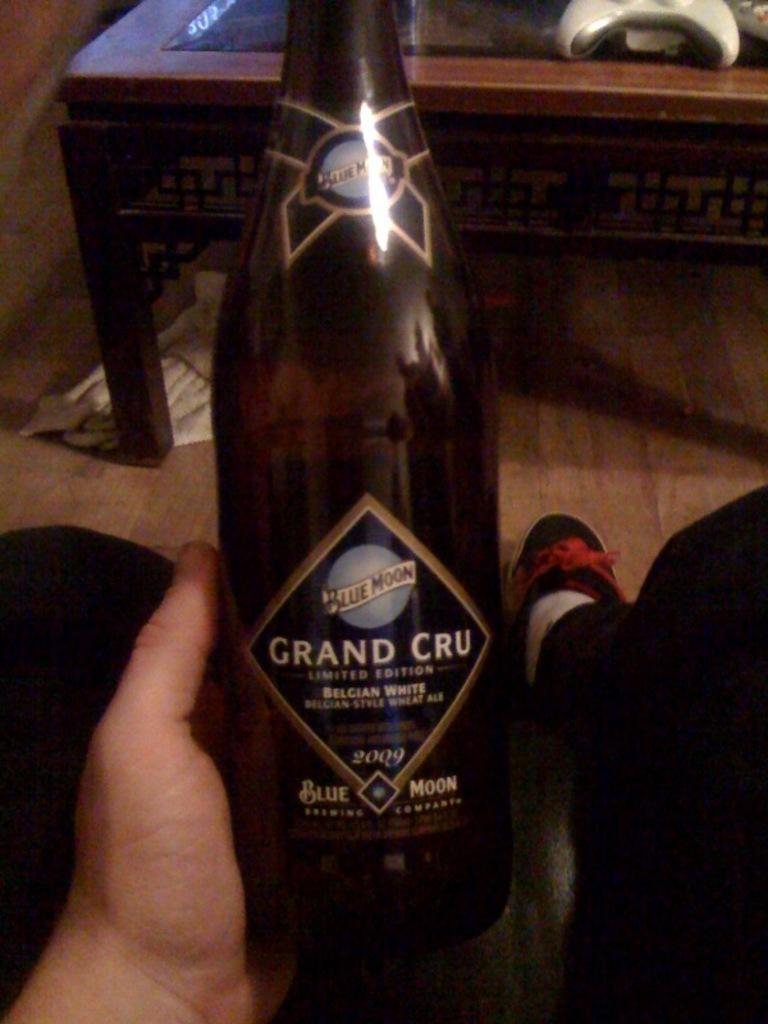Provide a one-sentence caption for the provided image. A large bottle of beer named Grand Cru distributed by Blue Moon. 